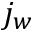<formula> <loc_0><loc_0><loc_500><loc_500>j _ { w }</formula> 